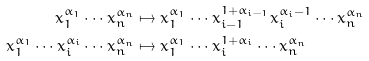Convert formula to latex. <formula><loc_0><loc_0><loc_500><loc_500>x _ { 1 } ^ { \alpha _ { 1 } } \cdots x _ { n } ^ { \alpha _ { n } } & \mapsto x _ { 1 } ^ { \alpha _ { 1 } } \cdots x _ { i - 1 } ^ { 1 + \alpha _ { i - 1 } } x _ { i } ^ { \alpha _ { i } - 1 } \cdots x _ { n } ^ { \alpha _ { n } } \\ x _ { 1 } ^ { \alpha _ { 1 } } \cdots x _ { i } ^ { \alpha _ { i } } \cdots x _ { n } ^ { \alpha _ { n } } & \mapsto x _ { 1 } ^ { \alpha _ { 1 } } \cdots x _ { i } ^ { 1 + \alpha _ { i } } \cdots x _ { n } ^ { \alpha _ { n } }</formula> 